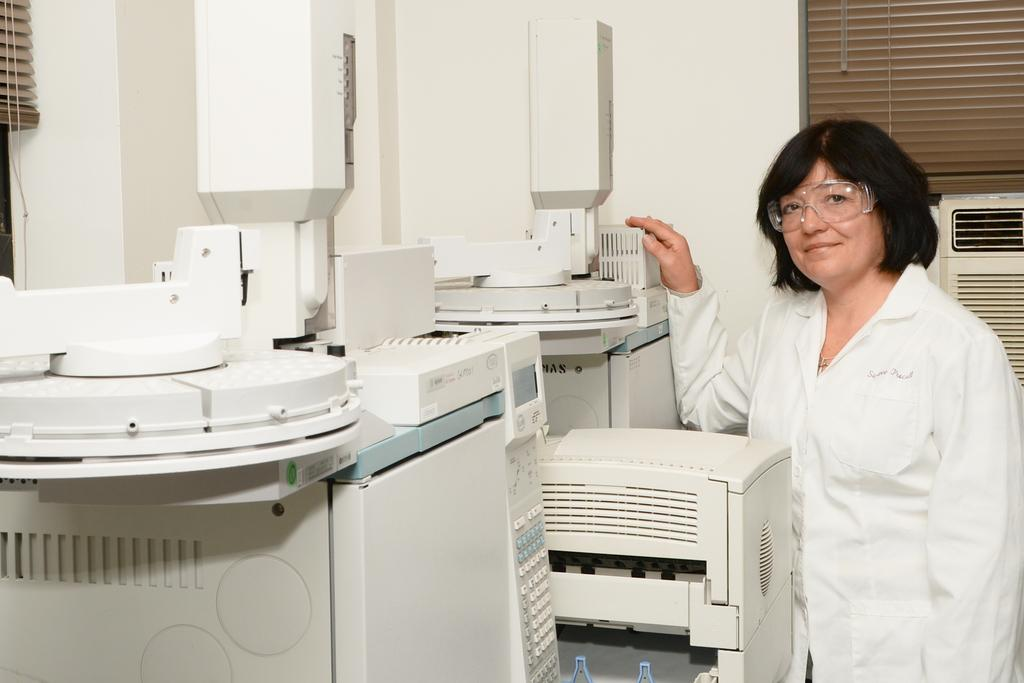What can be seen in the image? There are machines in the image. Who is present in the image? A woman is standing beside the machine. What is visible in the background of the image? There is a wall in the background of the image. Can you describe the wall in the image? There is a window in the wall. What type of chess move is the woman making in the image? There is no chess board or pieces present in the image, so it is not possible to determine if the woman is making a chess move. 